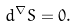<formula> <loc_0><loc_0><loc_500><loc_500>d ^ { \nabla } S = 0 .</formula> 